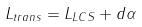Convert formula to latex. <formula><loc_0><loc_0><loc_500><loc_500>L _ { t r a n s } = L _ { L C S } + d \alpha</formula> 